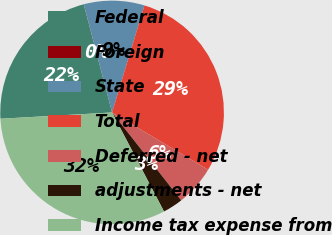Convert chart to OTSL. <chart><loc_0><loc_0><loc_500><loc_500><pie_chart><fcel>Federal<fcel>Foreign<fcel>State<fcel>Total<fcel>Deferred - net<fcel>adjustments - net<fcel>Income tax expense from<nl><fcel>21.81%<fcel>0.01%<fcel>8.75%<fcel>28.88%<fcel>5.83%<fcel>2.92%<fcel>31.79%<nl></chart> 